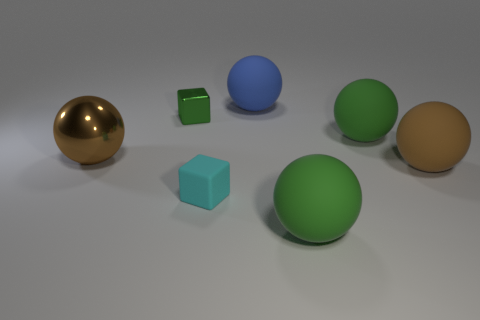Subtract all shiny spheres. How many spheres are left? 4 Add 1 large shiny objects. How many objects exist? 8 Subtract all spheres. How many objects are left? 2 Add 1 cyan matte objects. How many cyan matte objects are left? 2 Add 6 brown things. How many brown things exist? 8 Subtract all cyan blocks. How many blocks are left? 1 Subtract 0 yellow spheres. How many objects are left? 7 Subtract 1 blocks. How many blocks are left? 1 Subtract all purple spheres. Subtract all blue cylinders. How many spheres are left? 5 Subtract all blue balls. How many green blocks are left? 1 